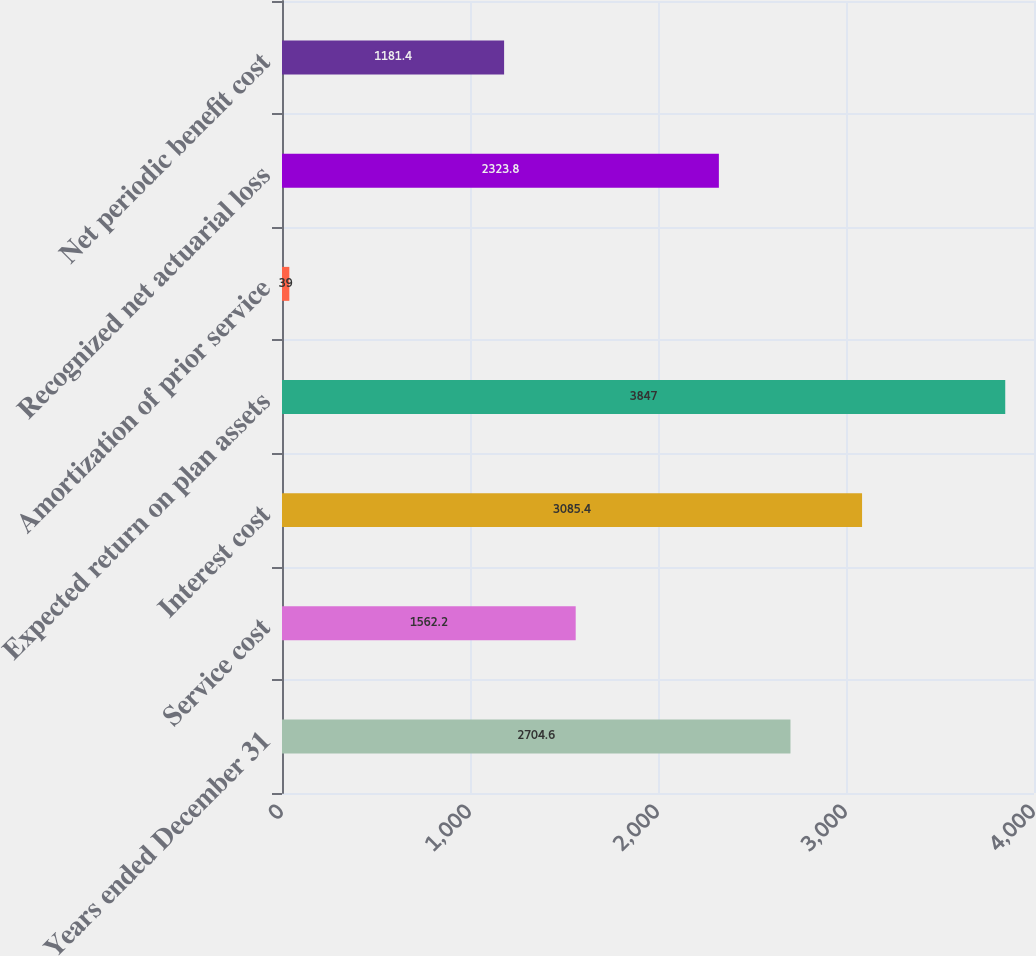Convert chart. <chart><loc_0><loc_0><loc_500><loc_500><bar_chart><fcel>Years ended December 31<fcel>Service cost<fcel>Interest cost<fcel>Expected return on plan assets<fcel>Amortization of prior service<fcel>Recognized net actuarial loss<fcel>Net periodic benefit cost<nl><fcel>2704.6<fcel>1562.2<fcel>3085.4<fcel>3847<fcel>39<fcel>2323.8<fcel>1181.4<nl></chart> 